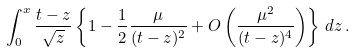<formula> <loc_0><loc_0><loc_500><loc_500>\int _ { 0 } ^ { x } { \frac { t - z } { \sqrt { z } } } \left \{ 1 - { \frac { 1 } { 2 } } { \frac { \mu } { ( t - z ) ^ { 2 } } } + O \left ( { \frac { \mu ^ { 2 } } { ( t - z ) ^ { 4 } } } \right ) \right \} \, d z \, .</formula> 